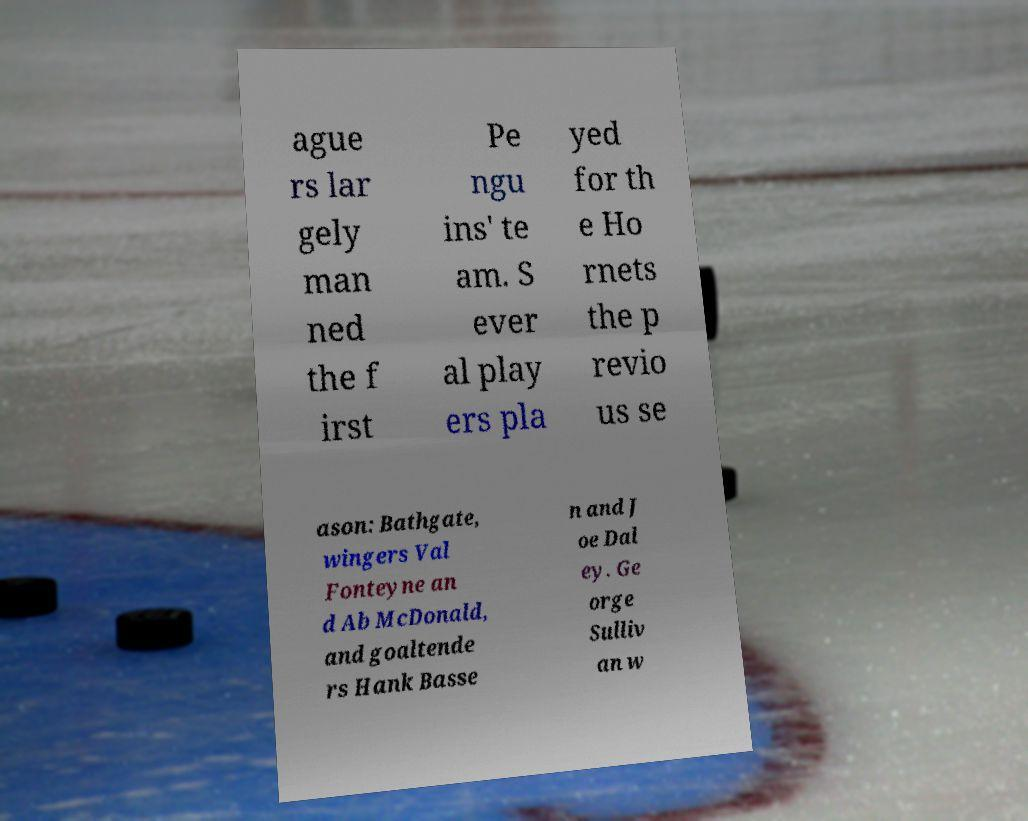I need the written content from this picture converted into text. Can you do that? ague rs lar gely man ned the f irst Pe ngu ins' te am. S ever al play ers pla yed for th e Ho rnets the p revio us se ason: Bathgate, wingers Val Fonteyne an d Ab McDonald, and goaltende rs Hank Basse n and J oe Dal ey. Ge orge Sulliv an w 